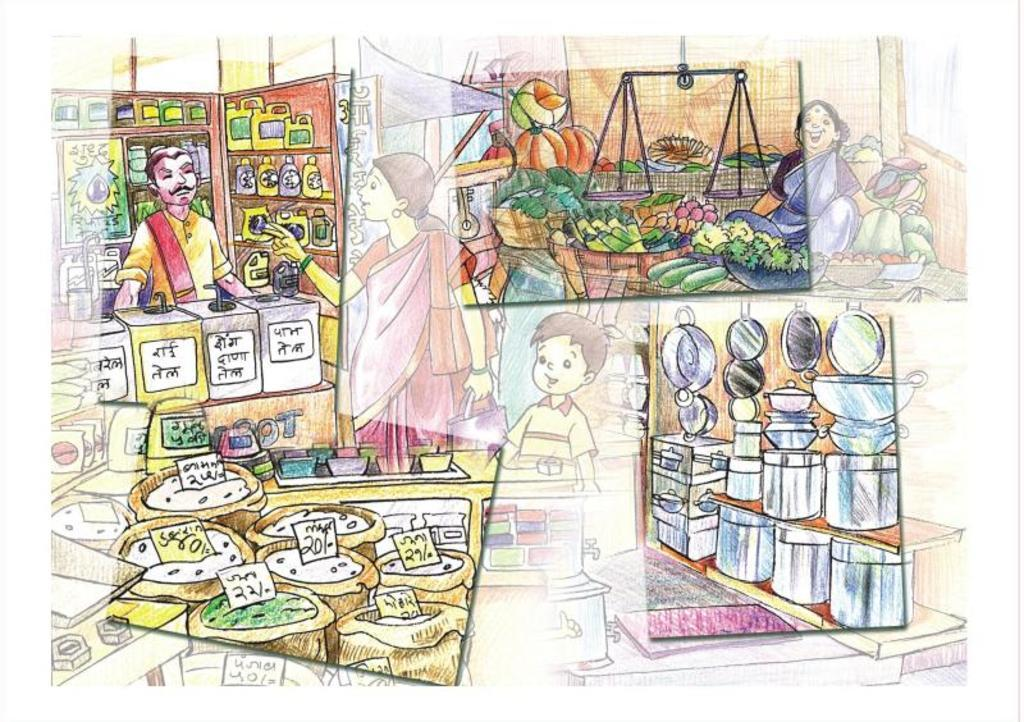What is the main subject of the image? The image contains a painting. What is being depicted in the painting? The painting depicts persons and includes vegetables, bags, price tags, bottles, bowls, plates, boxes, a weighing scale, and racks. What type of objects are present in the painting that might be used for storage or organization? Bags, boxes, and racks are depicted in the painting for storage or organization. What type of objects are present in the painting that might be used for serving or displaying food? Plates, bowls, and bottles are included in the painting for serving or displaying food. What type of tree can be seen in the painting? There is no tree present in the painting; it depicts a scene involving persons, vegetables, and various objects related to food and storage. 